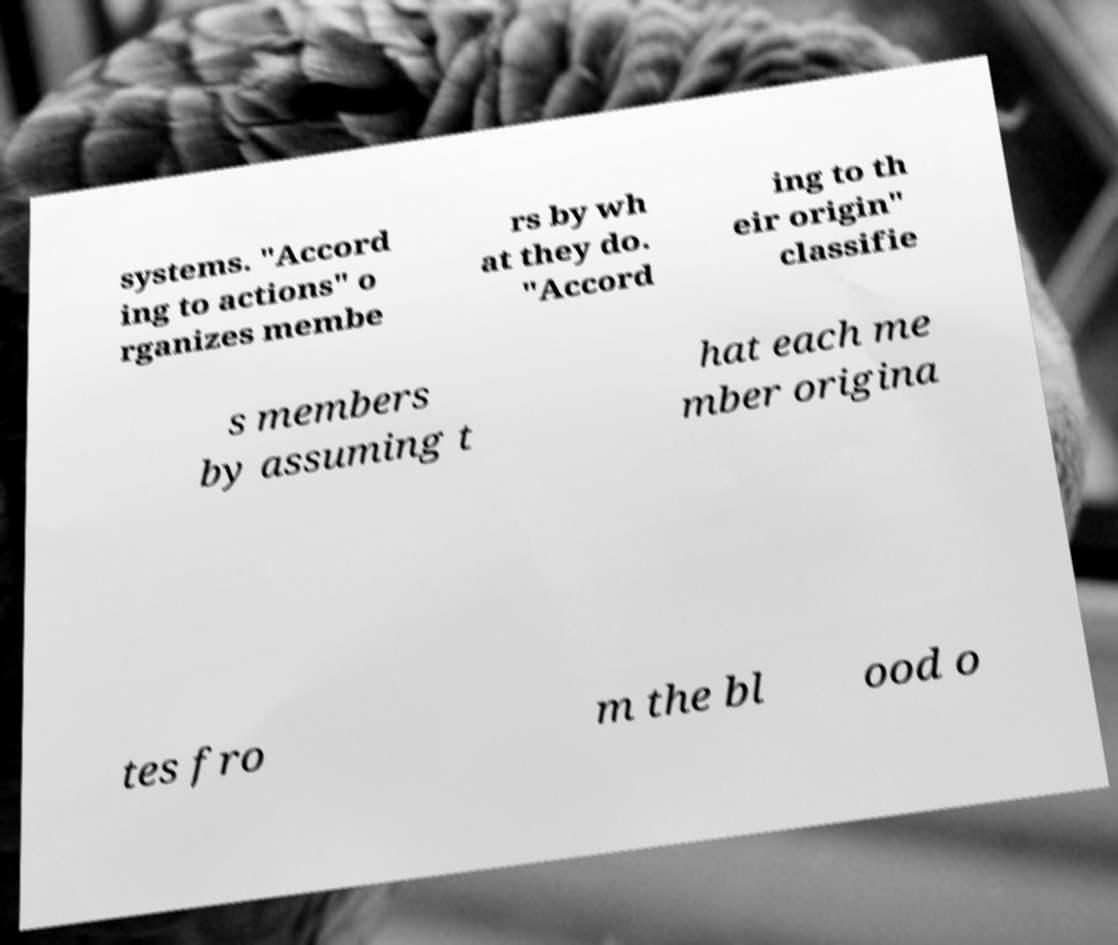What messages or text are displayed in this image? I need them in a readable, typed format. systems. "Accord ing to actions" o rganizes membe rs by wh at they do. "Accord ing to th eir origin" classifie s members by assuming t hat each me mber origina tes fro m the bl ood o 